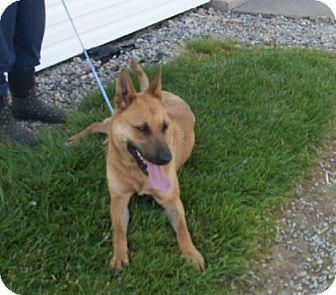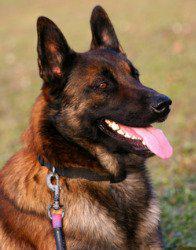The first image is the image on the left, the second image is the image on the right. Given the left and right images, does the statement "There are two dogs with pointed ears and tongues sticking out." hold true? Answer yes or no. Yes. The first image is the image on the left, the second image is the image on the right. For the images displayed, is the sentence "Each image contains a single german shepherd, and each dog wears a leash." factually correct? Answer yes or no. Yes. 